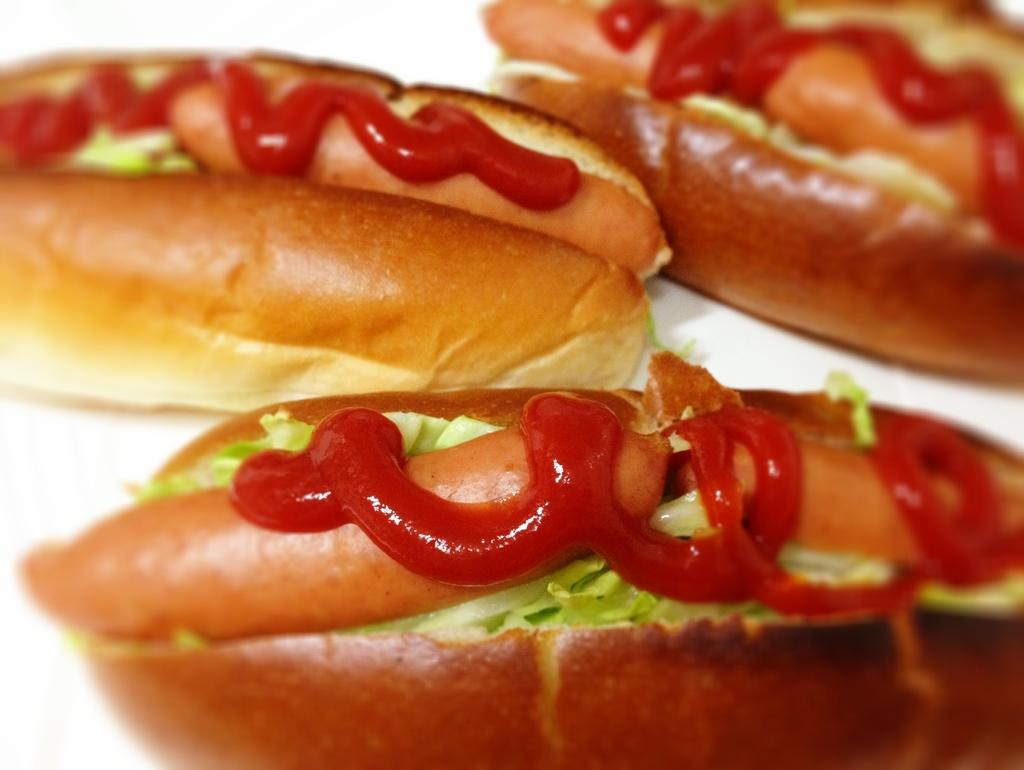What type of food is visible in the image? There are hot-dogs in the image. What accompanies the hot-dogs in the image? There is sauce on the hot-dogs. What type of ring can be seen on the hot-dogs in the image? There is no ring present on the hot-dogs in the image. What time of day is the image depicting, considering the presence of hot-dogs? The image does not provide any information about the time of day, and hot-dogs can be consumed at any time, including breakfast. What type of building is visible in the background of the image? There is no building visible in the image; it only features hot-dogs with sauce. 